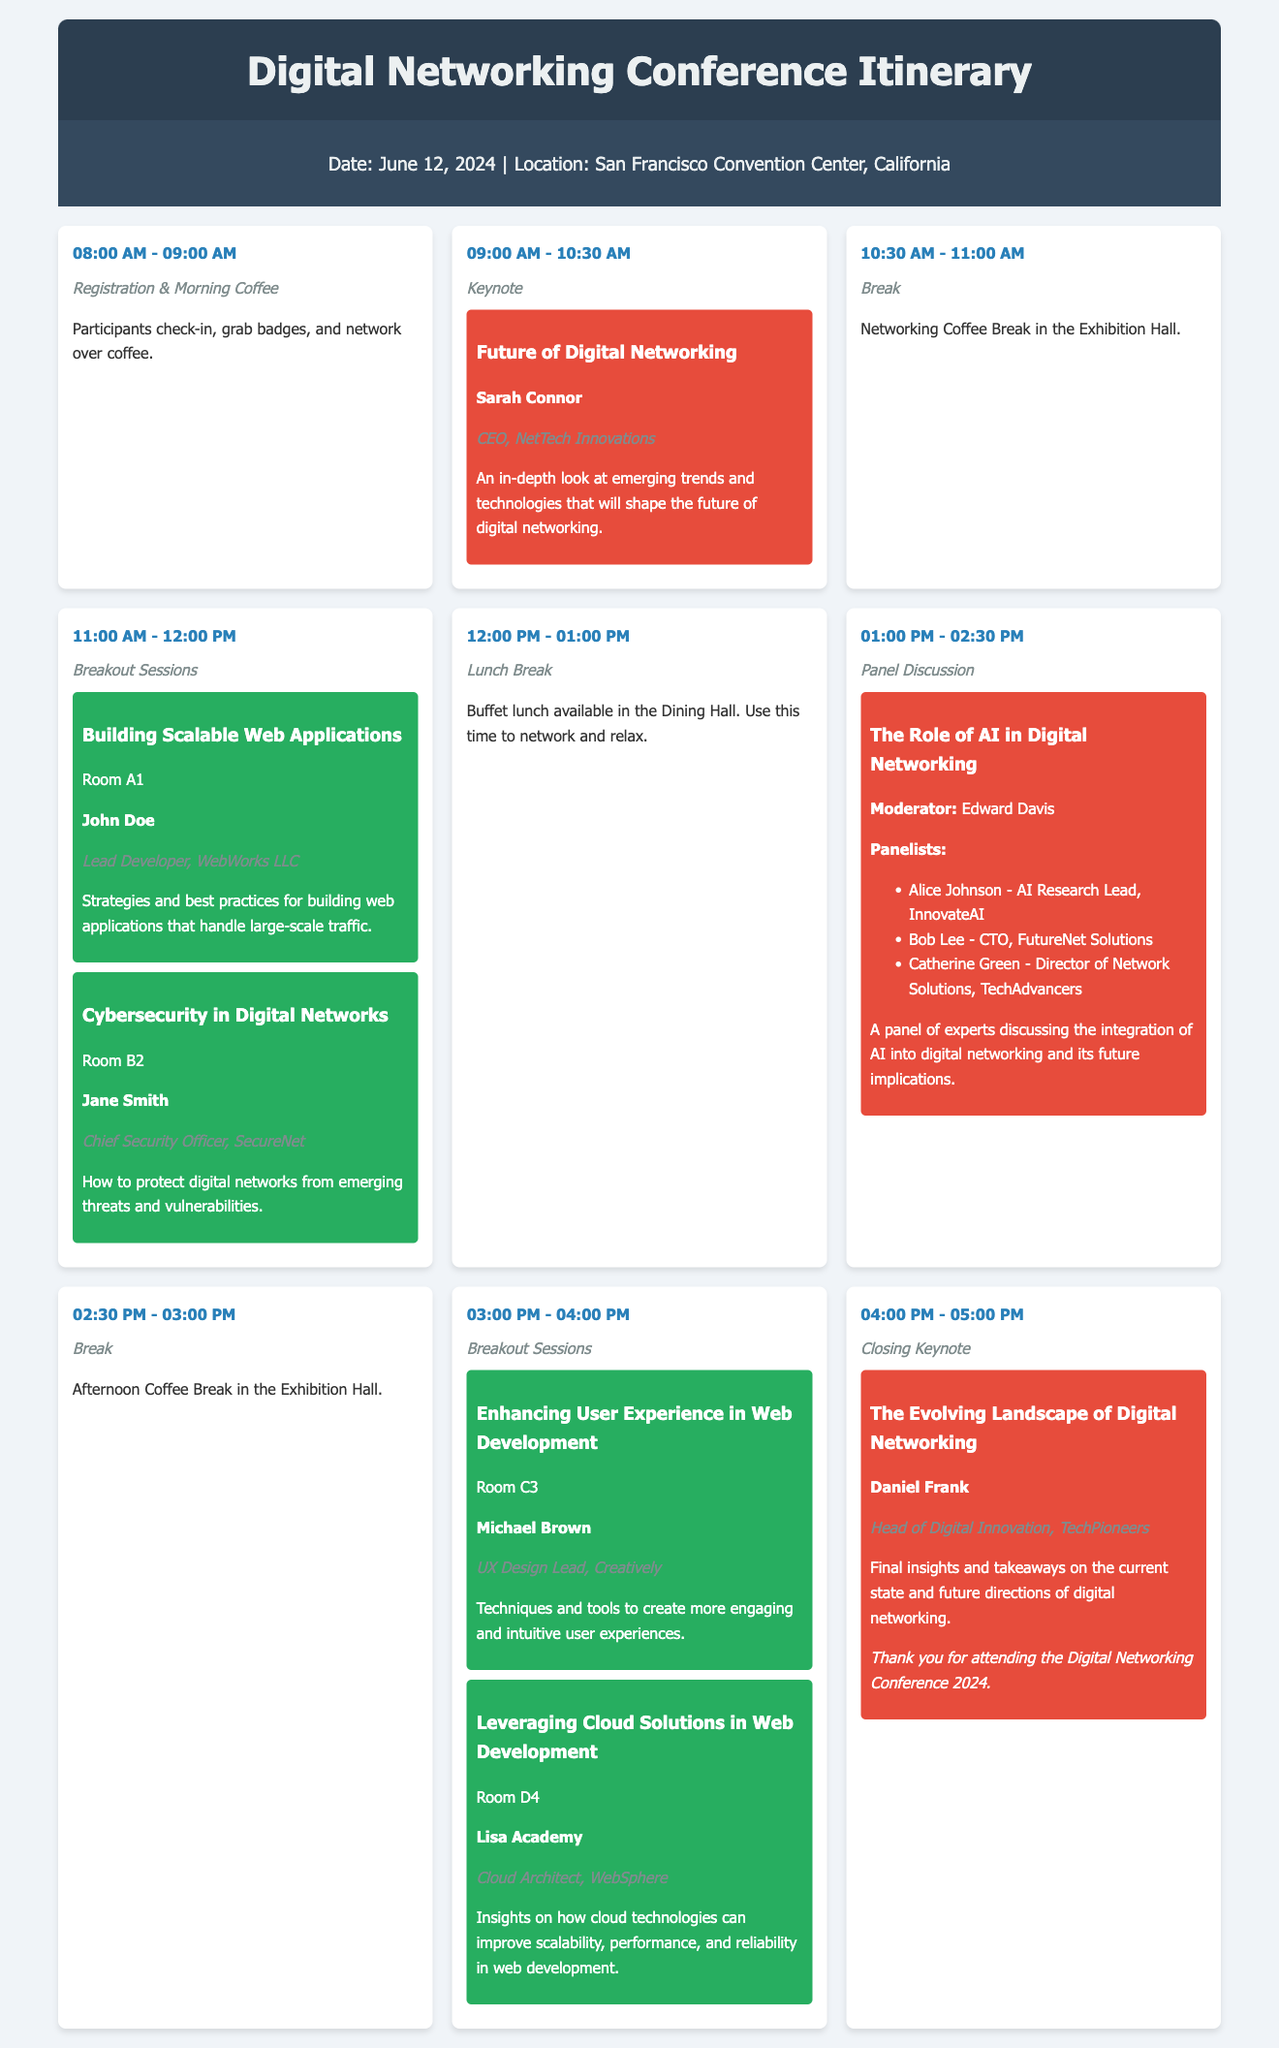What is the date of the conference? The date of the conference is explicitly stated in the document.
Answer: June 12, 2024 Who is the speaker for the keynote session? The keynote session lists a specific speaker in the schedule.
Answer: Sarah Connor What time does the lunch break start? The schedule provides specific times for each session, including the lunch break.
Answer: 12:00 PM How many breakout sessions are there in total? The document lists several breakout sessions throughout the schedule.
Answer: Four What is the title of the closing keynote? The title of the closing keynote is mentioned in the specified session.
Answer: The Evolving Landscape of Digital Networking Where is the conference located? The location of the conference is provided at the beginning of the document.
Answer: San Francisco Convention Center, California Who is the moderator for the panel discussion? The moderator for the panel discussion is explicitly named in the document.
Answer: Edward Davis What is the theme of the breakout session held in Room D4? The theme of the session is explicitly mentioned in the breakout session details.
Answer: Leveraging Cloud Solutions in Web Development What type of session follows the morning coffee break? The schedule indicates the type of session that occurs after the break.
Answer: Breakout Sessions 